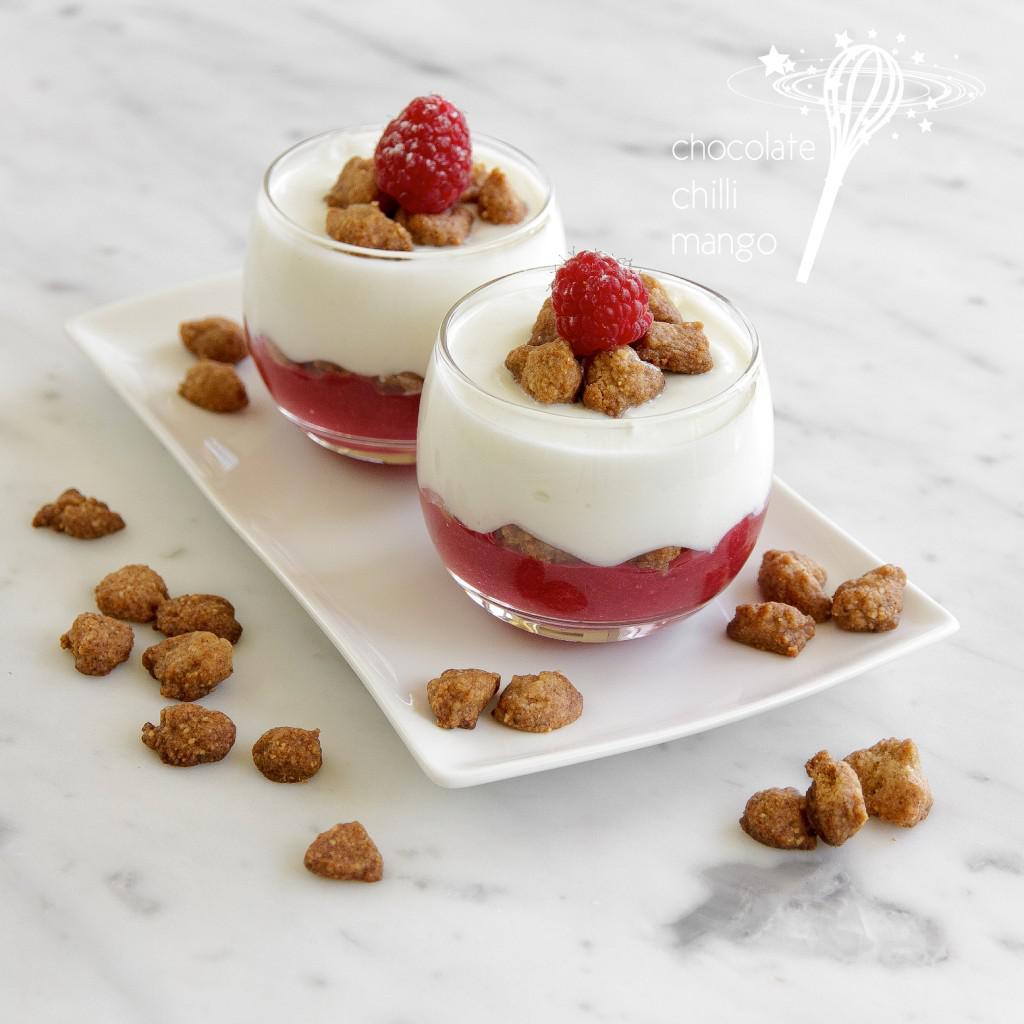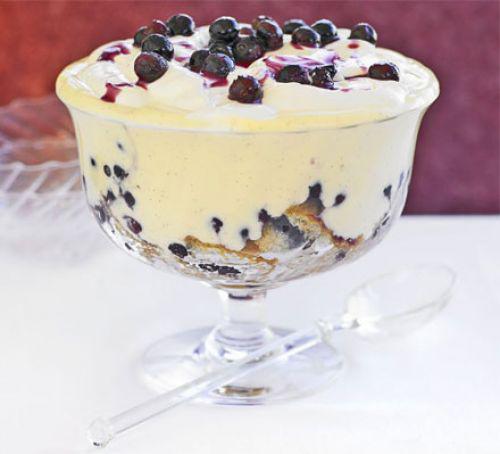The first image is the image on the left, the second image is the image on the right. Examine the images to the left and right. Is the description "The left image shows one dessert with one spoon." accurate? Answer yes or no. No. 